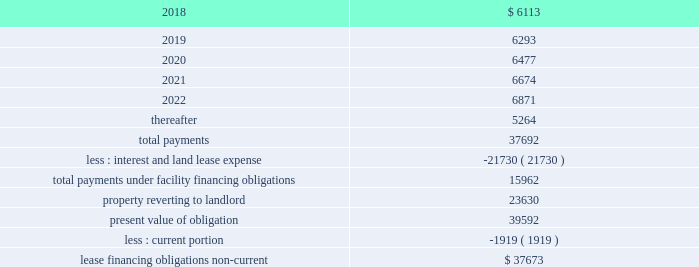As of december 31 , 2017 , the future minimum payments due under the lease financing obligation were as follows ( in thousands ) : years ending december 31 .
Purchase commitments we outsource most of our manufacturing and supply chain management operations to third-party contract manufacturers , who procure components and assemble products on our behalf based on our forecasts in order to reduce manufacturing lead times and ensure adequate component supply .
We issue purchase orders to our contract manufacturers for finished product and a significant portion of these orders consist of firm non-cancellable commitments .
In addition , we purchase strategic component inventory from certain suppliers under purchase commitments that in some cases are non-cancellable , including integrated circuits , which are consigned to our contract manufacturers .
As of december 31 , 2017 , we had non-cancellable purchase commitments of $ 195.1 million , of which $ 147.9 million was to our contract manufacturers and suppliers .
In addition , we have provided deposits to secure our obligations to purchase inventory .
We had $ 36.9 million and $ 63.1 million in deposits as of december 31 , 2017 and 2016 , respectively .
These deposits are classified in 'prepaid expenses and other current assets' and 'other assets' in our accompanying consolidated balance sheets .
Guarantees we have entered into agreements with some of our direct customers and channel partners that contain indemnification provisions relating to potential situations where claims could be alleged that our products infringe the intellectual property rights of a third party .
We have at our option and expense the ability to repair any infringement , replace product with a non-infringing equivalent-in-function product or refund our customers all or a portion of the value of the product .
Other guarantees or indemnification agreements include guarantees of product and service performance and standby letters of credit for leased facilities and corporate credit cards .
We have not recorded a liability related to these indemnification and guarantee provisions and our guarantee and indemnification arrangements have not had any significant impact on our consolidated financial statements to date .
Legal proceedings optumsoft , inc .
Matters on april 4 , 2014 , optumsoft filed a lawsuit against us in the superior court of california , santa clara county titled optumsoft , inc .
Arista networks , inc. , in which it asserts ( i ) ownership of certain components of our eos network operating system pursuant to the terms of a 2004 agreement between the companies ; and ( ii ) breaches of certain confidentiality and use restrictions in that agreement .
Under the terms of the 2004 agreement , optumsoft provided us with a non-exclusive , irrevocable , royalty-free license to software delivered by optumsoft comprising a software tool used to develop certain components of eos and a runtime library that is incorporated .
What percent of lease payments are due currently? 
Computations: (6113 / 37692)
Answer: 0.16218. 